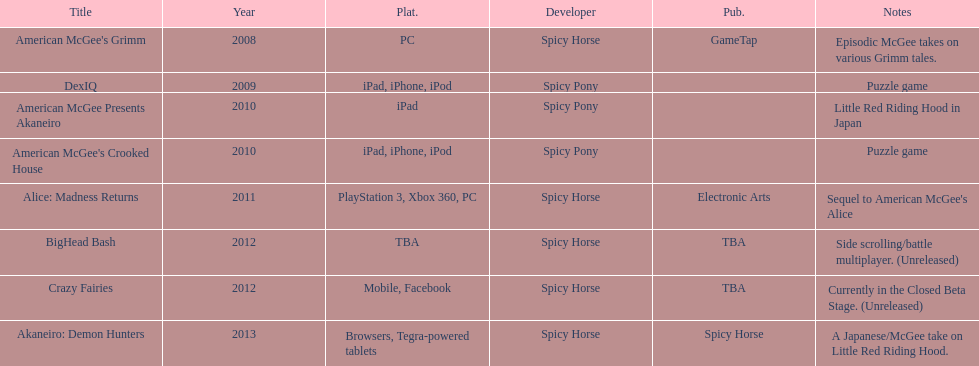What was the last game created by spicy horse Akaneiro: Demon Hunters. 